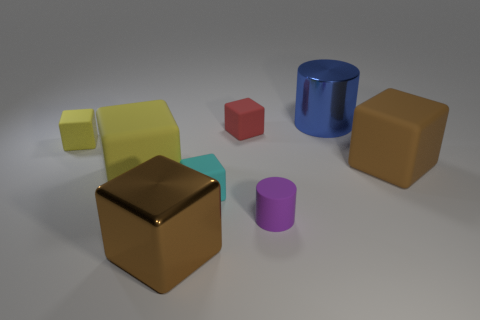What is the material of the other block that is the same color as the metal cube?
Offer a very short reply. Rubber. There is a rubber object that is the same color as the big metallic cube; what size is it?
Make the answer very short. Large. Is the number of small purple objects less than the number of large cyan metallic things?
Your response must be concise. No. Do the large rubber cube to the left of the big cylinder and the metal cube have the same color?
Your answer should be very brief. No. There is a large brown cube that is to the left of the brown thing on the right side of the large brown block left of the large blue metal cylinder; what is its material?
Your answer should be very brief. Metal. Are there any other big blocks of the same color as the large shiny cube?
Your answer should be very brief. Yes. Is the number of big brown blocks that are in front of the purple matte cylinder less than the number of rubber cylinders?
Your answer should be compact. No. There is a yellow block in front of the brown matte cube; is it the same size as the large brown metal block?
Your answer should be very brief. Yes. What number of big metal things are in front of the small yellow matte block and right of the tiny purple object?
Offer a very short reply. 0. There is a red matte cube that is on the right side of the brown object on the left side of the big metallic cylinder; how big is it?
Provide a succinct answer. Small. 